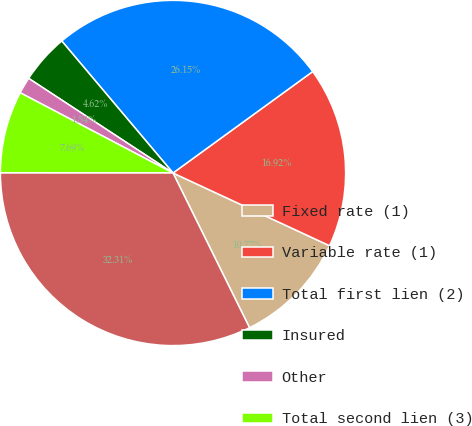Convert chart to OTSL. <chart><loc_0><loc_0><loc_500><loc_500><pie_chart><fcel>Fixed rate (1)<fcel>Variable rate (1)<fcel>Total first lien (2)<fcel>Insured<fcel>Other<fcel>Total second lien (3)<fcel>Total ABS RMBS<nl><fcel>10.77%<fcel>16.92%<fcel>26.15%<fcel>4.62%<fcel>1.54%<fcel>7.69%<fcel>32.31%<nl></chart> 